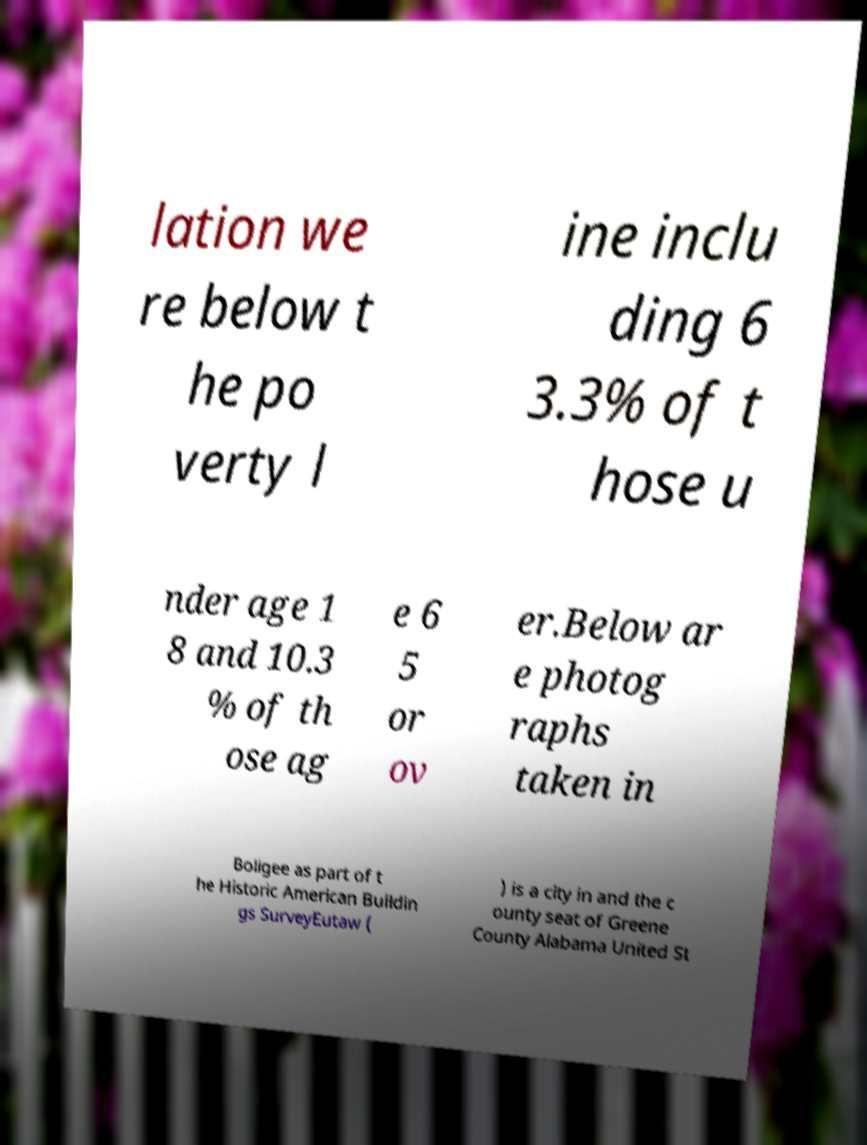What messages or text are displayed in this image? I need them in a readable, typed format. lation we re below t he po verty l ine inclu ding 6 3.3% of t hose u nder age 1 8 and 10.3 % of th ose ag e 6 5 or ov er.Below ar e photog raphs taken in Boligee as part of t he Historic American Buildin gs SurveyEutaw ( ) is a city in and the c ounty seat of Greene County Alabama United St 